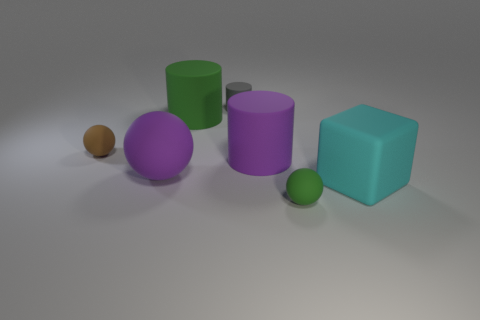There is a large thing to the right of the large purple thing to the right of the tiny gray rubber thing on the left side of the cyan rubber block; what shape is it?
Keep it short and to the point. Cube. Is there any other thing that is the same material as the tiny gray cylinder?
Make the answer very short. Yes. The purple rubber object that is the same shape as the tiny green thing is what size?
Your answer should be very brief. Large. What color is the small matte thing that is both behind the large cyan cube and right of the brown matte object?
Provide a short and direct response. Gray. Is the gray cylinder made of the same material as the green object in front of the large cyan matte block?
Your answer should be compact. Yes. Is the number of tiny balls that are in front of the big purple ball less than the number of cyan rubber cubes?
Offer a terse response. No. How many other things are the same shape as the gray matte object?
Your response must be concise. 2. Is there anything else of the same color as the tiny rubber cylinder?
Offer a terse response. No. There is a tiny cylinder; is its color the same as the tiny object that is to the right of the small gray matte object?
Your response must be concise. No. How many other things are the same size as the brown sphere?
Provide a succinct answer. 2. 